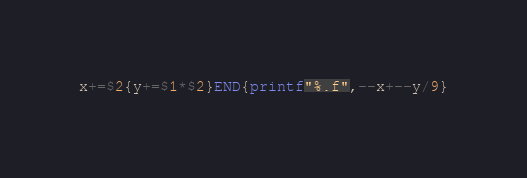Convert code to text. <code><loc_0><loc_0><loc_500><loc_500><_Awk_>x+=$2{y+=$1*$2}END{printf"%.f",--x+--y/9}</code> 